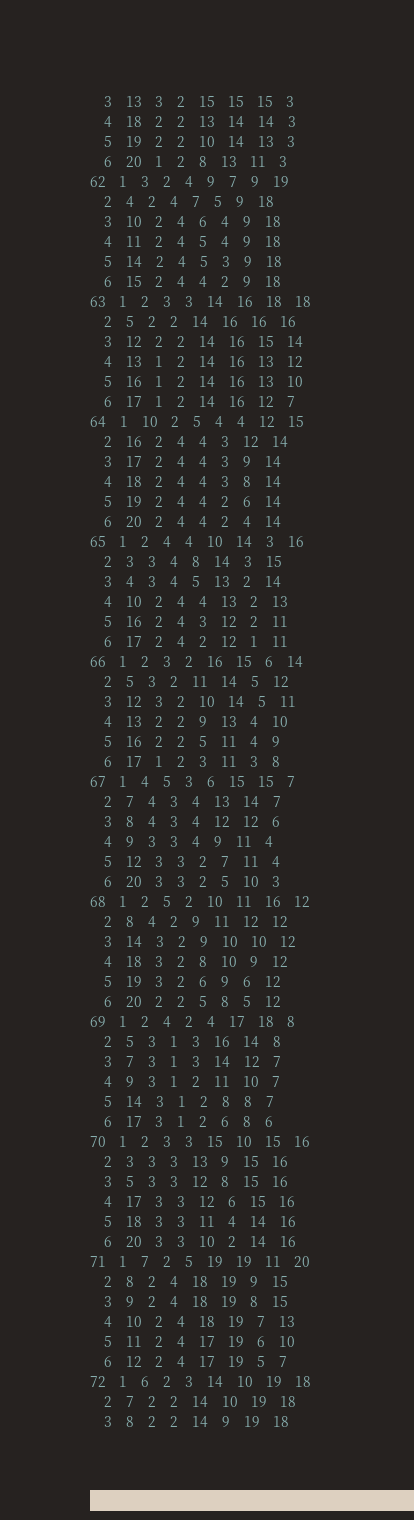<code> <loc_0><loc_0><loc_500><loc_500><_ObjectiveC_>	3	13	3	2	15	15	15	3	
	4	18	2	2	13	14	14	3	
	5	19	2	2	10	14	13	3	
	6	20	1	2	8	13	11	3	
62	1	3	2	4	9	7	9	19	
	2	4	2	4	7	5	9	18	
	3	10	2	4	6	4	9	18	
	4	11	2	4	5	4	9	18	
	5	14	2	4	5	3	9	18	
	6	15	2	4	4	2	9	18	
63	1	2	3	3	14	16	18	18	
	2	5	2	2	14	16	16	16	
	3	12	2	2	14	16	15	14	
	4	13	1	2	14	16	13	12	
	5	16	1	2	14	16	13	10	
	6	17	1	2	14	16	12	7	
64	1	10	2	5	4	4	12	15	
	2	16	2	4	4	3	12	14	
	3	17	2	4	4	3	9	14	
	4	18	2	4	4	3	8	14	
	5	19	2	4	4	2	6	14	
	6	20	2	4	4	2	4	14	
65	1	2	4	4	10	14	3	16	
	2	3	3	4	8	14	3	15	
	3	4	3	4	5	13	2	14	
	4	10	2	4	4	13	2	13	
	5	16	2	4	3	12	2	11	
	6	17	2	4	2	12	1	11	
66	1	2	3	2	16	15	6	14	
	2	5	3	2	11	14	5	12	
	3	12	3	2	10	14	5	11	
	4	13	2	2	9	13	4	10	
	5	16	2	2	5	11	4	9	
	6	17	1	2	3	11	3	8	
67	1	4	5	3	6	15	15	7	
	2	7	4	3	4	13	14	7	
	3	8	4	3	4	12	12	6	
	4	9	3	3	4	9	11	4	
	5	12	3	3	2	7	11	4	
	6	20	3	3	2	5	10	3	
68	1	2	5	2	10	11	16	12	
	2	8	4	2	9	11	12	12	
	3	14	3	2	9	10	10	12	
	4	18	3	2	8	10	9	12	
	5	19	3	2	6	9	6	12	
	6	20	2	2	5	8	5	12	
69	1	2	4	2	4	17	18	8	
	2	5	3	1	3	16	14	8	
	3	7	3	1	3	14	12	7	
	4	9	3	1	2	11	10	7	
	5	14	3	1	2	8	8	7	
	6	17	3	1	2	6	8	6	
70	1	2	3	3	15	10	15	16	
	2	3	3	3	13	9	15	16	
	3	5	3	3	12	8	15	16	
	4	17	3	3	12	6	15	16	
	5	18	3	3	11	4	14	16	
	6	20	3	3	10	2	14	16	
71	1	7	2	5	19	19	11	20	
	2	8	2	4	18	19	9	15	
	3	9	2	4	18	19	8	15	
	4	10	2	4	18	19	7	13	
	5	11	2	4	17	19	6	10	
	6	12	2	4	17	19	5	7	
72	1	6	2	3	14	10	19	18	
	2	7	2	2	14	10	19	18	
	3	8	2	2	14	9	19	18	</code> 